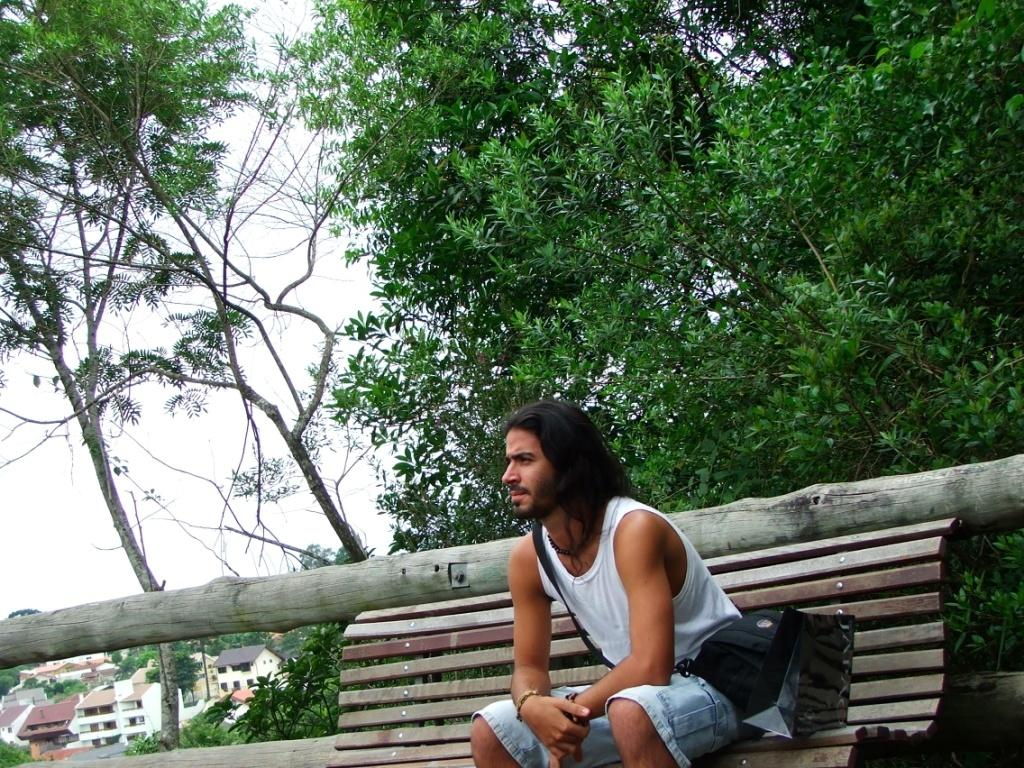Who is present in the image? There is a man in the image. What is the man doing in the image? The man is seated on a bench. What can be seen beside the bench in the image? There are trees beside the bench. What is visible in the background of the image? There are houses visible in the background of the image. What type of oil is being used by the man in the image? There is no oil present in the image, and the man is not using any oil. What does the man need to do in the image? The image does not provide any information about what the man needs to do, as it only shows him seated on a bench. 